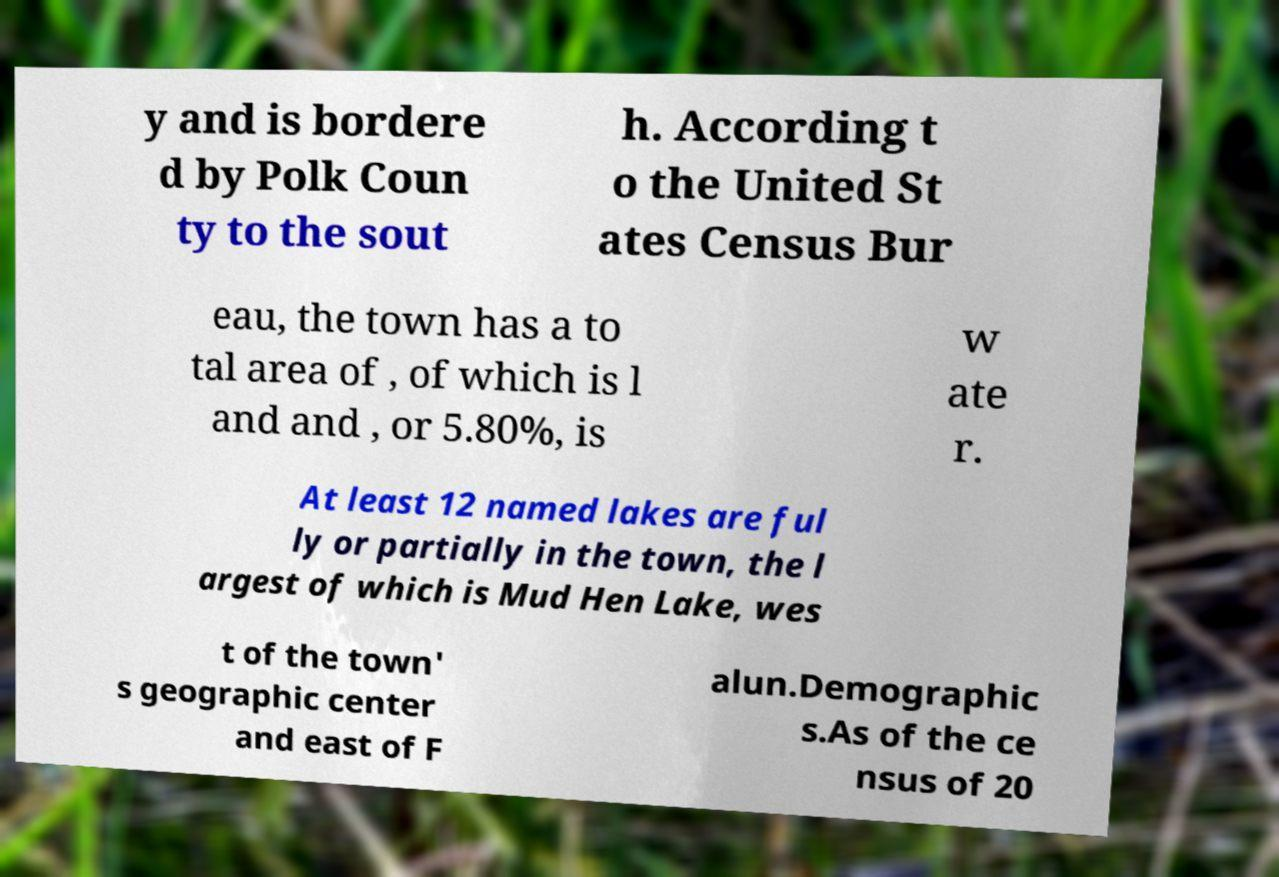Can you read and provide the text displayed in the image?This photo seems to have some interesting text. Can you extract and type it out for me? y and is bordere d by Polk Coun ty to the sout h. According t o the United St ates Census Bur eau, the town has a to tal area of , of which is l and and , or 5.80%, is w ate r. At least 12 named lakes are ful ly or partially in the town, the l argest of which is Mud Hen Lake, wes t of the town' s geographic center and east of F alun.Demographic s.As of the ce nsus of 20 